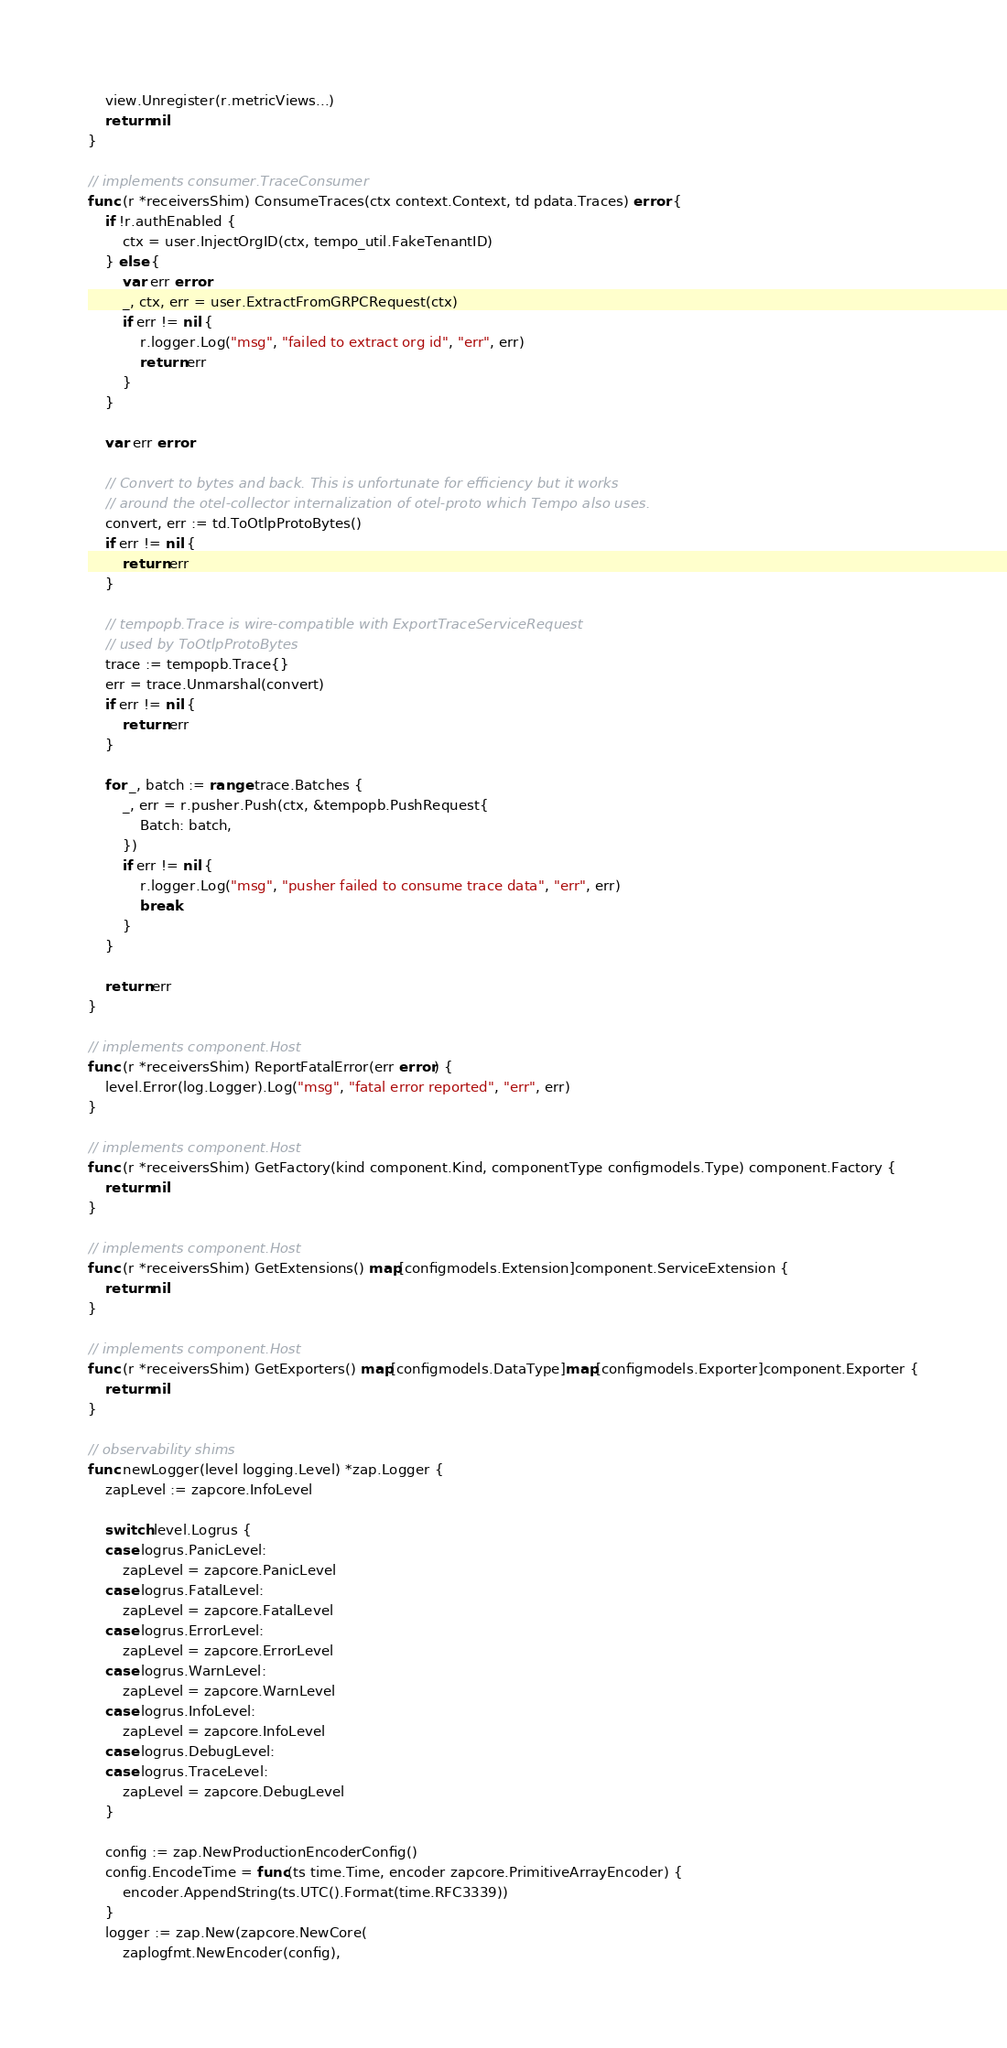<code> <loc_0><loc_0><loc_500><loc_500><_Go_>	view.Unregister(r.metricViews...)
	return nil
}

// implements consumer.TraceConsumer
func (r *receiversShim) ConsumeTraces(ctx context.Context, td pdata.Traces) error {
	if !r.authEnabled {
		ctx = user.InjectOrgID(ctx, tempo_util.FakeTenantID)
	} else {
		var err error
		_, ctx, err = user.ExtractFromGRPCRequest(ctx)
		if err != nil {
			r.logger.Log("msg", "failed to extract org id", "err", err)
			return err
		}
	}

	var err error

	// Convert to bytes and back. This is unfortunate for efficiency but it works
	// around the otel-collector internalization of otel-proto which Tempo also uses.
	convert, err := td.ToOtlpProtoBytes()
	if err != nil {
		return err
	}

	// tempopb.Trace is wire-compatible with ExportTraceServiceRequest
	// used by ToOtlpProtoBytes
	trace := tempopb.Trace{}
	err = trace.Unmarshal(convert)
	if err != nil {
		return err
	}

	for _, batch := range trace.Batches {
		_, err = r.pusher.Push(ctx, &tempopb.PushRequest{
			Batch: batch,
		})
		if err != nil {
			r.logger.Log("msg", "pusher failed to consume trace data", "err", err)
			break
		}
	}

	return err
}

// implements component.Host
func (r *receiversShim) ReportFatalError(err error) {
	level.Error(log.Logger).Log("msg", "fatal error reported", "err", err)
}

// implements component.Host
func (r *receiversShim) GetFactory(kind component.Kind, componentType configmodels.Type) component.Factory {
	return nil
}

// implements component.Host
func (r *receiversShim) GetExtensions() map[configmodels.Extension]component.ServiceExtension {
	return nil
}

// implements component.Host
func (r *receiversShim) GetExporters() map[configmodels.DataType]map[configmodels.Exporter]component.Exporter {
	return nil
}

// observability shims
func newLogger(level logging.Level) *zap.Logger {
	zapLevel := zapcore.InfoLevel

	switch level.Logrus {
	case logrus.PanicLevel:
		zapLevel = zapcore.PanicLevel
	case logrus.FatalLevel:
		zapLevel = zapcore.FatalLevel
	case logrus.ErrorLevel:
		zapLevel = zapcore.ErrorLevel
	case logrus.WarnLevel:
		zapLevel = zapcore.WarnLevel
	case logrus.InfoLevel:
		zapLevel = zapcore.InfoLevel
	case logrus.DebugLevel:
	case logrus.TraceLevel:
		zapLevel = zapcore.DebugLevel
	}

	config := zap.NewProductionEncoderConfig()
	config.EncodeTime = func(ts time.Time, encoder zapcore.PrimitiveArrayEncoder) {
		encoder.AppendString(ts.UTC().Format(time.RFC3339))
	}
	logger := zap.New(zapcore.NewCore(
		zaplogfmt.NewEncoder(config),</code> 